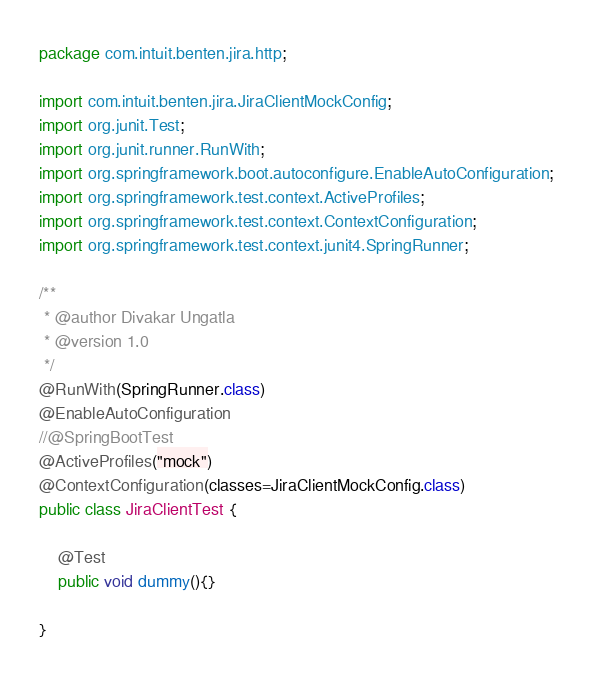Convert code to text. <code><loc_0><loc_0><loc_500><loc_500><_Java_>package com.intuit.benten.jira.http;

import com.intuit.benten.jira.JiraClientMockConfig;
import org.junit.Test;
import org.junit.runner.RunWith;
import org.springframework.boot.autoconfigure.EnableAutoConfiguration;
import org.springframework.test.context.ActiveProfiles;
import org.springframework.test.context.ContextConfiguration;
import org.springframework.test.context.junit4.SpringRunner;

/**
 * @author Divakar Ungatla
 * @version 1.0
 */
@RunWith(SpringRunner.class)
@EnableAutoConfiguration
//@SpringBootTest
@ActiveProfiles("mock")
@ContextConfiguration(classes=JiraClientMockConfig.class)
public class JiraClientTest {

    @Test
    public void dummy(){}

}
</code> 